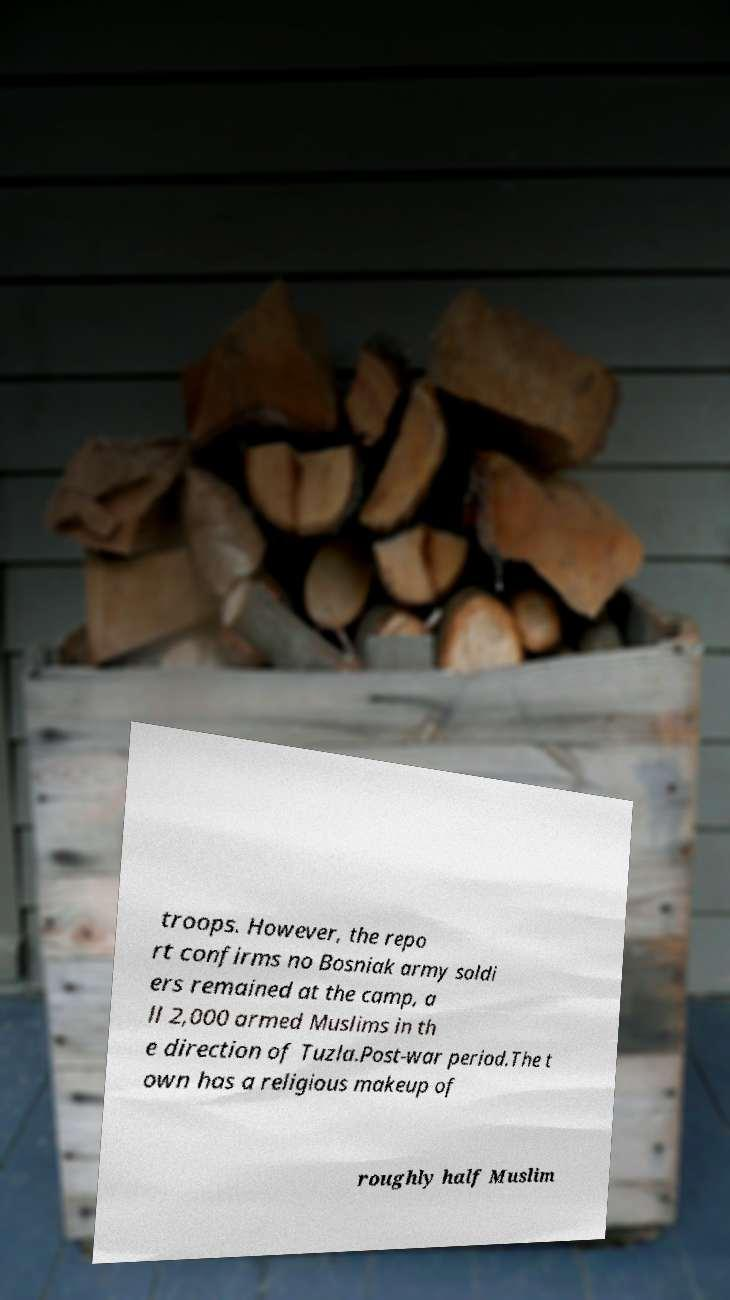Could you extract and type out the text from this image? troops. However, the repo rt confirms no Bosniak army soldi ers remained at the camp, a ll 2,000 armed Muslims in th e direction of Tuzla.Post-war period.The t own has a religious makeup of roughly half Muslim 